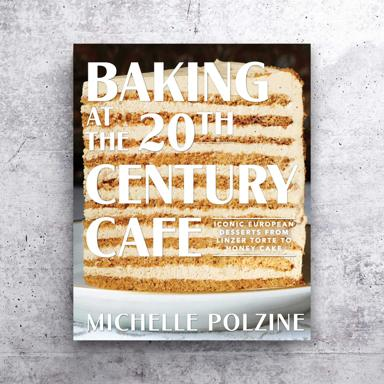Can you tell us more about the author, Michelle Polzine, and her culinary background? Michelle Polzine is renowned for her deep appreciation and revival of traditional European dessert techniques. She has gained a reputation for meticulously recreating classic desserts with attention to authenticity and details. Michelle’s expertise and passion for European baking traditions shine through in her meticulously crafted recipes. 